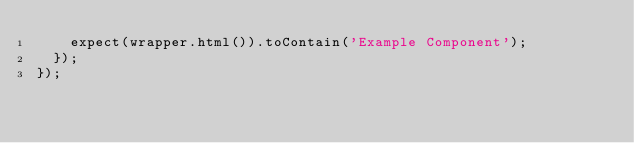<code> <loc_0><loc_0><loc_500><loc_500><_JavaScript_>    expect(wrapper.html()).toContain('Example Component');
  });
});
</code> 